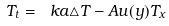<formula> <loc_0><loc_0><loc_500><loc_500>T _ { t } = \ k a \triangle T - A u ( y ) T _ { x }</formula> 